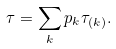<formula> <loc_0><loc_0><loc_500><loc_500>\tau = \sum _ { k } p _ { k } \tau _ { ( k ) } .</formula> 